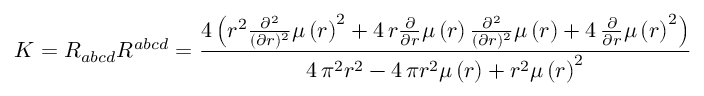<formula> <loc_0><loc_0><loc_500><loc_500>K = R _ { a b c d } R ^ { a b c d } = \frac { 4 \, { \left ( r ^ { 2 } \frac { \partial ^ { 2 } } { ( \partial r ) ^ { 2 } } \mu \left ( r \right ) ^ { 2 } + 4 \, r \frac { \partial } { \partial r } \mu \left ( r \right ) \frac { \partial ^ { 2 } } { ( \partial r ) ^ { 2 } } \mu \left ( r \right ) + 4 \, \frac { \partial } { \partial r } \mu \left ( r \right ) ^ { 2 } \right ) } } { 4 \, \pi ^ { 2 } r ^ { 2 } - 4 \, \pi r ^ { 2 } \mu \left ( r \right ) + r ^ { 2 } \mu \left ( r \right ) ^ { 2 } }</formula> 